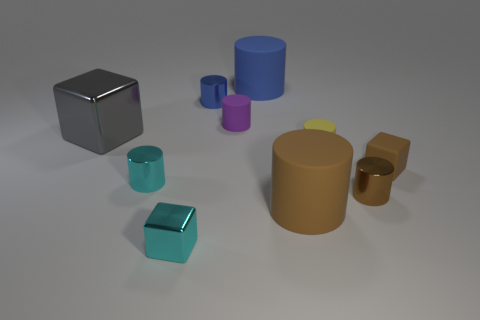There is a metallic cylinder that is to the right of the shiny cylinder behind the small yellow rubber object; what size is it?
Your response must be concise. Small. What number of brown blocks have the same size as the gray cube?
Your answer should be very brief. 0. There is a cylinder in front of the tiny brown metal cylinder; does it have the same color as the cube that is in front of the cyan cylinder?
Give a very brief answer. No. There is a tiny brown cylinder; are there any small things behind it?
Offer a terse response. Yes. What color is the large object that is behind the brown metallic cylinder and right of the purple rubber object?
Your response must be concise. Blue. Are there any tiny metallic cubes that have the same color as the large metal thing?
Ensure brevity in your answer.  No. Are the cube in front of the brown shiny cylinder and the large cylinder that is in front of the gray metallic cube made of the same material?
Provide a succinct answer. No. There is a object that is behind the blue shiny object; what size is it?
Your answer should be very brief. Large. The yellow matte cylinder is what size?
Provide a short and direct response. Small. How big is the cyan object that is behind the brown object that is left of the tiny metallic object that is right of the purple rubber cylinder?
Offer a terse response. Small. 